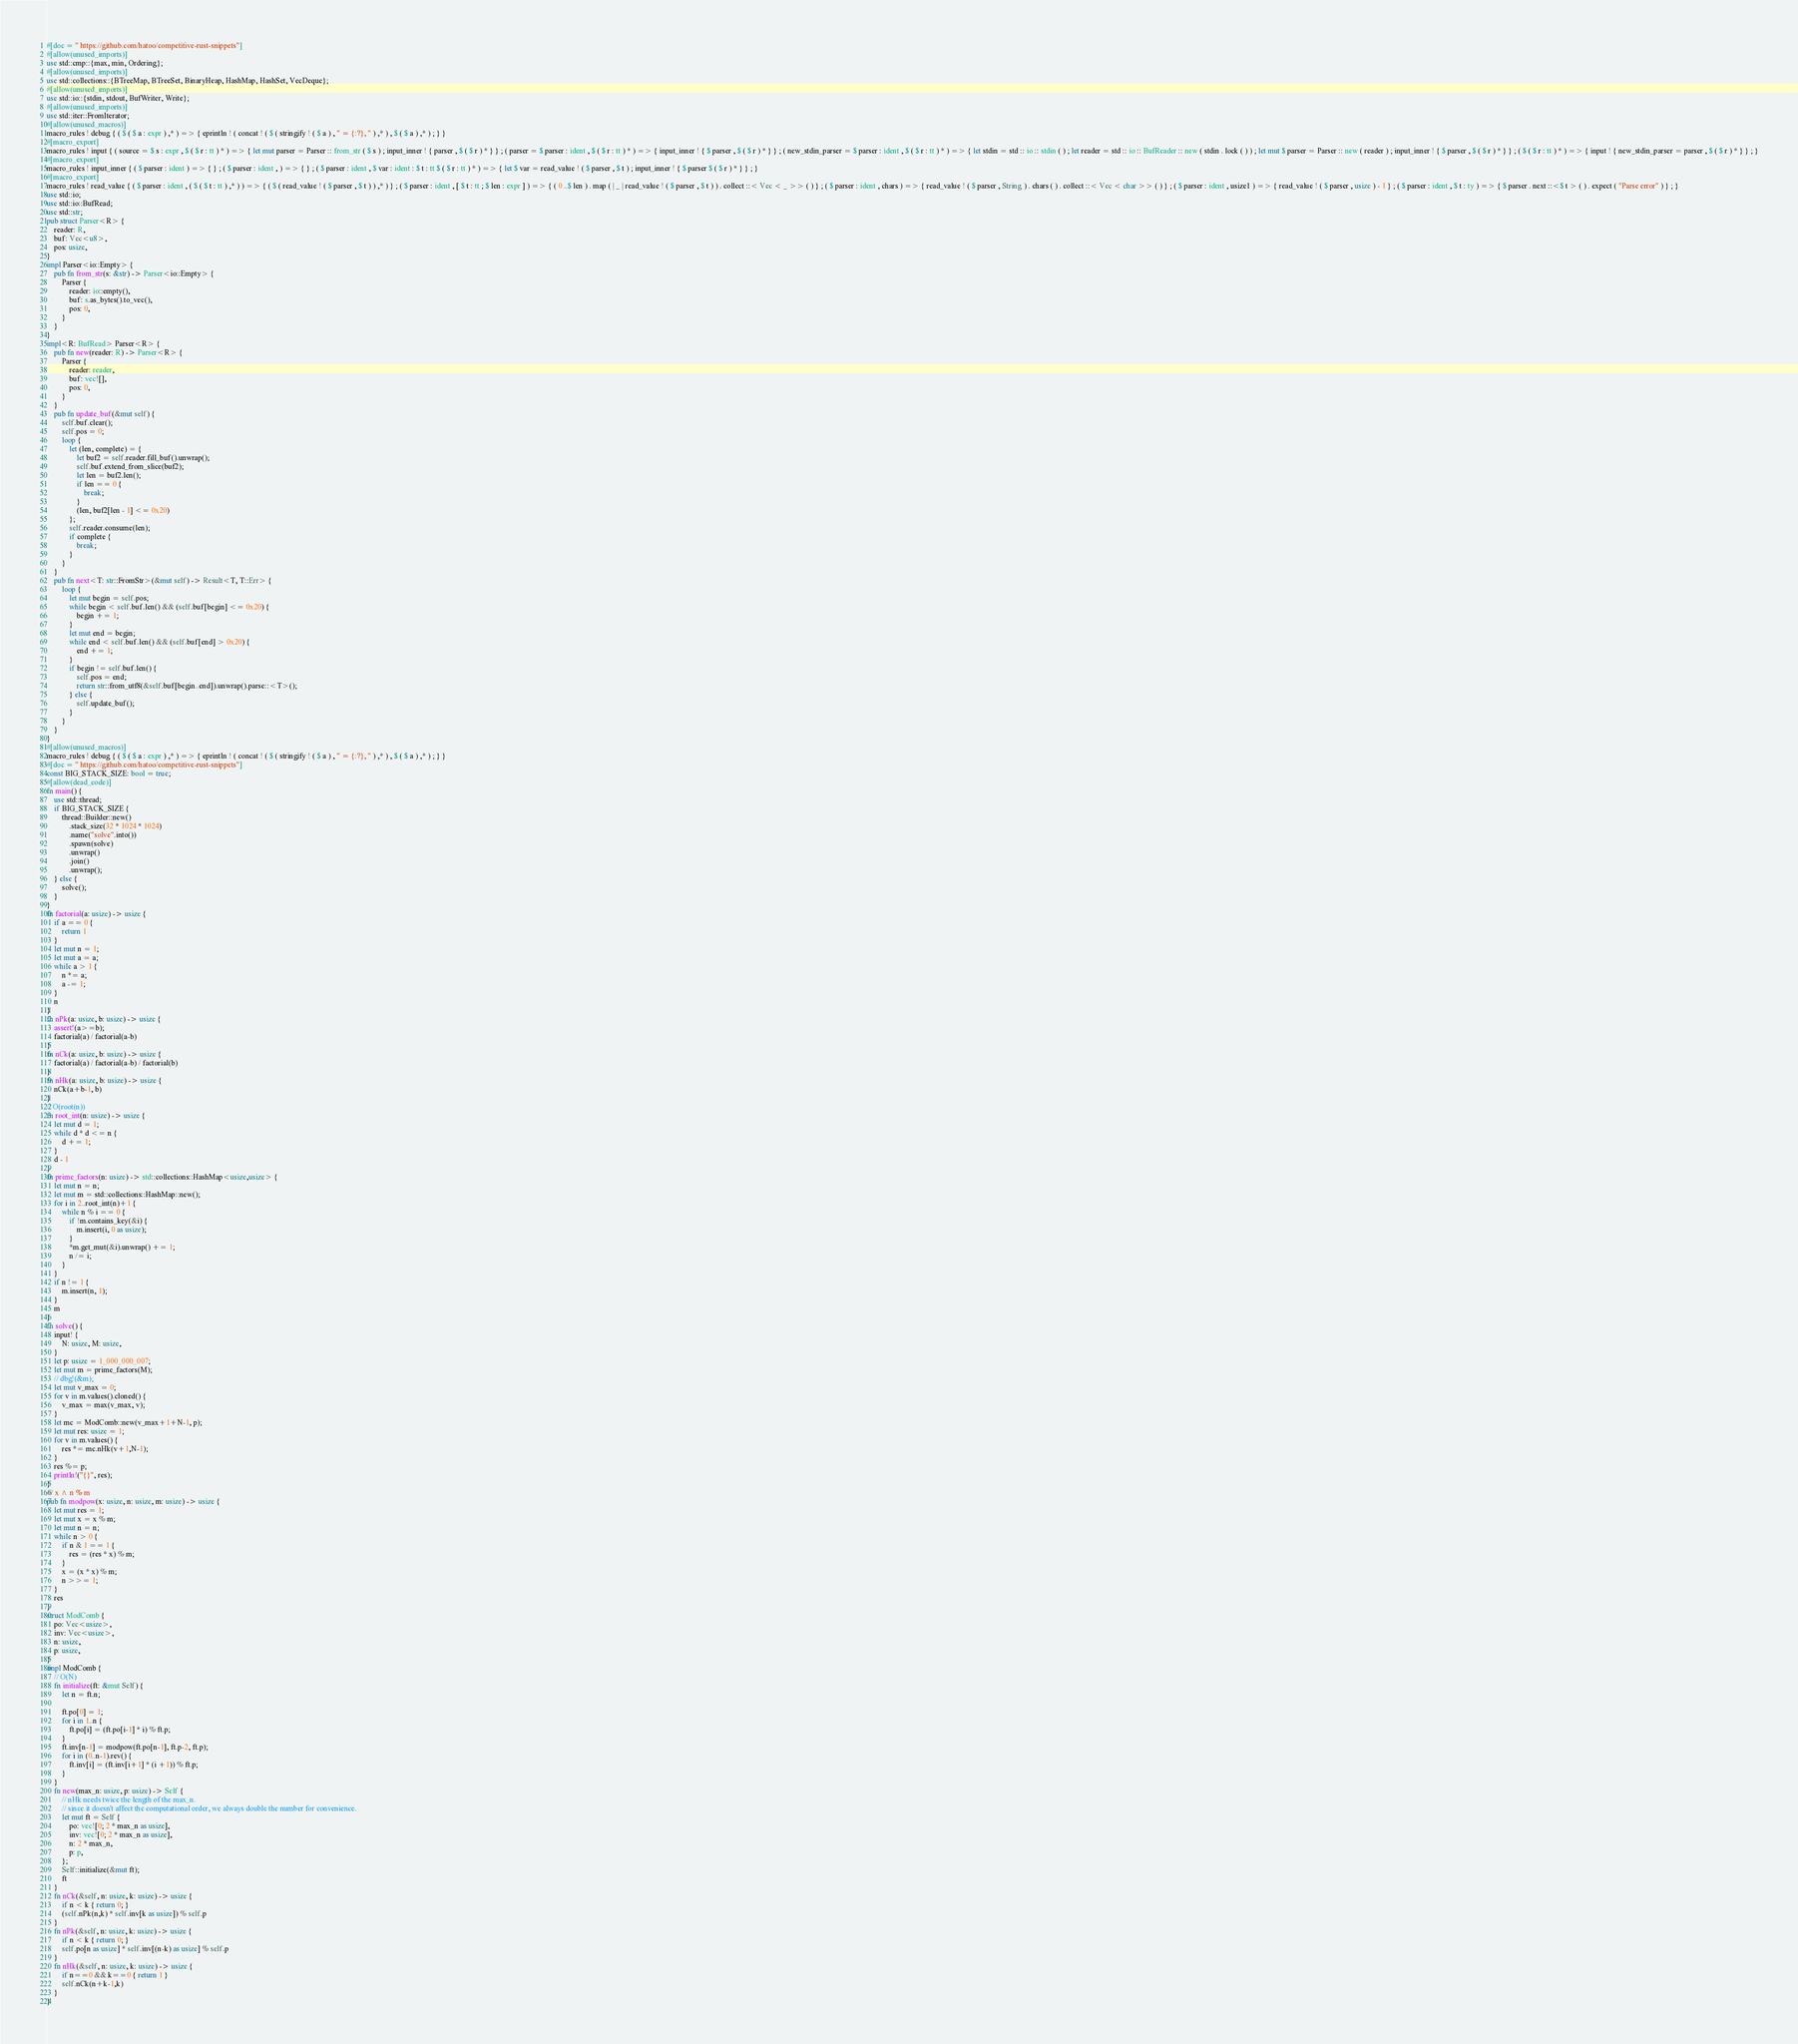<code> <loc_0><loc_0><loc_500><loc_500><_Rust_>#[doc = " https://github.com/hatoo/competitive-rust-snippets"]
#[allow(unused_imports)]
use std::cmp::{max, min, Ordering};
#[allow(unused_imports)]
use std::collections::{BTreeMap, BTreeSet, BinaryHeap, HashMap, HashSet, VecDeque};
#[allow(unused_imports)]
use std::io::{stdin, stdout, BufWriter, Write};
#[allow(unused_imports)]
use std::iter::FromIterator;
#[allow(unused_macros)]
macro_rules ! debug { ( $ ( $ a : expr ) ,* ) => { eprintln ! ( concat ! ( $ ( stringify ! ( $ a ) , " = {:?}, " ) ,* ) , $ ( $ a ) ,* ) ; } }
#[macro_export]
macro_rules ! input { ( source = $ s : expr , $ ( $ r : tt ) * ) => { let mut parser = Parser :: from_str ( $ s ) ; input_inner ! { parser , $ ( $ r ) * } } ; ( parser = $ parser : ident , $ ( $ r : tt ) * ) => { input_inner ! { $ parser , $ ( $ r ) * } } ; ( new_stdin_parser = $ parser : ident , $ ( $ r : tt ) * ) => { let stdin = std :: io :: stdin ( ) ; let reader = std :: io :: BufReader :: new ( stdin . lock ( ) ) ; let mut $ parser = Parser :: new ( reader ) ; input_inner ! { $ parser , $ ( $ r ) * } } ; ( $ ( $ r : tt ) * ) => { input ! { new_stdin_parser = parser , $ ( $ r ) * } } ; }
#[macro_export]
macro_rules ! input_inner { ( $ parser : ident ) => { } ; ( $ parser : ident , ) => { } ; ( $ parser : ident , $ var : ident : $ t : tt $ ( $ r : tt ) * ) => { let $ var = read_value ! ( $ parser , $ t ) ; input_inner ! { $ parser $ ( $ r ) * } } ; }
#[macro_export]
macro_rules ! read_value { ( $ parser : ident , ( $ ( $ t : tt ) ,* ) ) => { ( $ ( read_value ! ( $ parser , $ t ) ) ,* ) } ; ( $ parser : ident , [ $ t : tt ; $ len : expr ] ) => { ( 0 ..$ len ) . map ( | _ | read_value ! ( $ parser , $ t ) ) . collect ::< Vec < _ >> ( ) } ; ( $ parser : ident , chars ) => { read_value ! ( $ parser , String ) . chars ( ) . collect ::< Vec < char >> ( ) } ; ( $ parser : ident , usize1 ) => { read_value ! ( $ parser , usize ) - 1 } ; ( $ parser : ident , $ t : ty ) => { $ parser . next ::<$ t > ( ) . expect ( "Parse error" ) } ; }
use std::io;
use std::io::BufRead;
use std::str;
pub struct Parser<R> {
    reader: R,
    buf: Vec<u8>,
    pos: usize,
}
impl Parser<io::Empty> {
    pub fn from_str(s: &str) -> Parser<io::Empty> {
        Parser {
            reader: io::empty(),
            buf: s.as_bytes().to_vec(),
            pos: 0,
        }
    }
}
impl<R: BufRead> Parser<R> {
    pub fn new(reader: R) -> Parser<R> {
        Parser {
            reader: reader,
            buf: vec![],
            pos: 0,
        }
    }
    pub fn update_buf(&mut self) {
        self.buf.clear();
        self.pos = 0;
        loop {
            let (len, complete) = {
                let buf2 = self.reader.fill_buf().unwrap();
                self.buf.extend_from_slice(buf2);
                let len = buf2.len();
                if len == 0 {
                    break;
                }
                (len, buf2[len - 1] <= 0x20)
            };
            self.reader.consume(len);
            if complete {
                break;
            }
        }
    }
    pub fn next<T: str::FromStr>(&mut self) -> Result<T, T::Err> {
        loop {
            let mut begin = self.pos;
            while begin < self.buf.len() && (self.buf[begin] <= 0x20) {
                begin += 1;
            }
            let mut end = begin;
            while end < self.buf.len() && (self.buf[end] > 0x20) {
                end += 1;
            }
            if begin != self.buf.len() {
                self.pos = end;
                return str::from_utf8(&self.buf[begin..end]).unwrap().parse::<T>();
            } else {
                self.update_buf();
            }
        }
    }
}
#[allow(unused_macros)]
macro_rules ! debug { ( $ ( $ a : expr ) ,* ) => { eprintln ! ( concat ! ( $ ( stringify ! ( $ a ) , " = {:?}, " ) ,* ) , $ ( $ a ) ,* ) ; } }
#[doc = " https://github.com/hatoo/competitive-rust-snippets"]
const BIG_STACK_SIZE: bool = true;
#[allow(dead_code)]
fn main() {
    use std::thread;
    if BIG_STACK_SIZE {
        thread::Builder::new()
            .stack_size(32 * 1024 * 1024)
            .name("solve".into())
            .spawn(solve)
            .unwrap()
            .join()
            .unwrap();
    } else {
        solve();
    }
}
fn factorial(a: usize) -> usize {
    if a == 0 {
        return 1
    }
    let mut n = 1;
    let mut a = a;
    while a > 1 {
        n *= a;
        a -= 1;
    }
    n
}
fn nPk(a: usize, b: usize) -> usize {
    assert!(a>=b);
    factorial(a) / factorial(a-b)
}
fn nCk(a: usize, b: usize) -> usize {
    factorial(a) / factorial(a-b) / factorial(b)
}
fn nHk(a: usize, b: usize) -> usize {
    nCk(a+b-1, b)
}
// O(root(n))
fn root_int(n: usize) -> usize {
    let mut d = 1;
    while d * d <= n {
        d += 1;
    }
    d - 1
}
fn prime_factors(n: usize) -> std::collections::HashMap<usize,usize> {
    let mut n = n;
    let mut m = std::collections::HashMap::new();
    for i in 2..root_int(n)+1 {
        while n % i == 0 {
            if !m.contains_key(&i) {
                m.insert(i, 0 as usize);
            }
            *m.get_mut(&i).unwrap() += 1;
            n /= i;
        }
    }
    if n != 1 {
        m.insert(n, 1);
    }
    m
}
fn solve() {
    input! {
        N: usize, M: usize,
    }
    let p: usize = 1_000_000_007;
    let mut m = prime_factors(M);
    // dbg!(&m);
    let mut v_max = 0;
    for v in m.values().cloned() {
        v_max = max(v_max, v);
    }
    let mc = ModComb::new(v_max+1+N-1, p);
    let mut res: usize = 1;
    for v in m.values() {
        res *= mc.nHk(v+1,N-1);
    }
    res %= p;
    println!("{}", res);
}
/// x ^ n % m
pub fn modpow(x: usize, n: usize, m: usize) -> usize {
    let mut res = 1;
    let mut x = x % m;
    let mut n = n;
    while n > 0 {
        if n & 1 == 1 {
            res = (res * x) % m;
        }
        x = (x * x) % m;
        n >>= 1;
    }
    res
}
struct ModComb {
    po: Vec<usize>,
    inv: Vec<usize>,
    n: usize,
    p: usize,
}
impl ModComb {
    // O(N)
    fn initialize(ft: &mut Self) {
        let n = ft.n;

        ft.po[0] = 1;
        for i in 1..n {
            ft.po[i] = (ft.po[i-1] * i) % ft.p;
        }
        ft.inv[n-1] = modpow(ft.po[n-1], ft.p-2, ft.p);
        for i in (0..n-1).rev() {
            ft.inv[i] = (ft.inv[i+1] * (i +1)) % ft.p;
        }
    }
    fn new(max_n: usize, p: usize) -> Self {
        // nHk needs twice the length of the max_n.
        // since it doesn't affect the computational order, we always double the number for convenience.
        let mut ft = Self {
            po: vec![0; 2 * max_n as usize],
            inv: vec![0; 2 * max_n as usize],
            n: 2 * max_n,
            p: p,
        };
        Self::initialize(&mut ft);
        ft
    }
    fn nCk(&self, n: usize, k: usize) -> usize {
        if n < k { return 0; }
        (self.nPk(n,k) * self.inv[k as usize]) % self.p 
    }
    fn nPk(&self, n: usize, k: usize) -> usize {
        if n < k { return 0; }
        self.po[n as usize] * self.inv[(n-k) as usize] % self.p
    }
    fn nHk(&self, n: usize, k: usize) -> usize {
        if n==0 && k==0 { return 1 }
        self.nCk(n+k-1,k)
    }
}</code> 